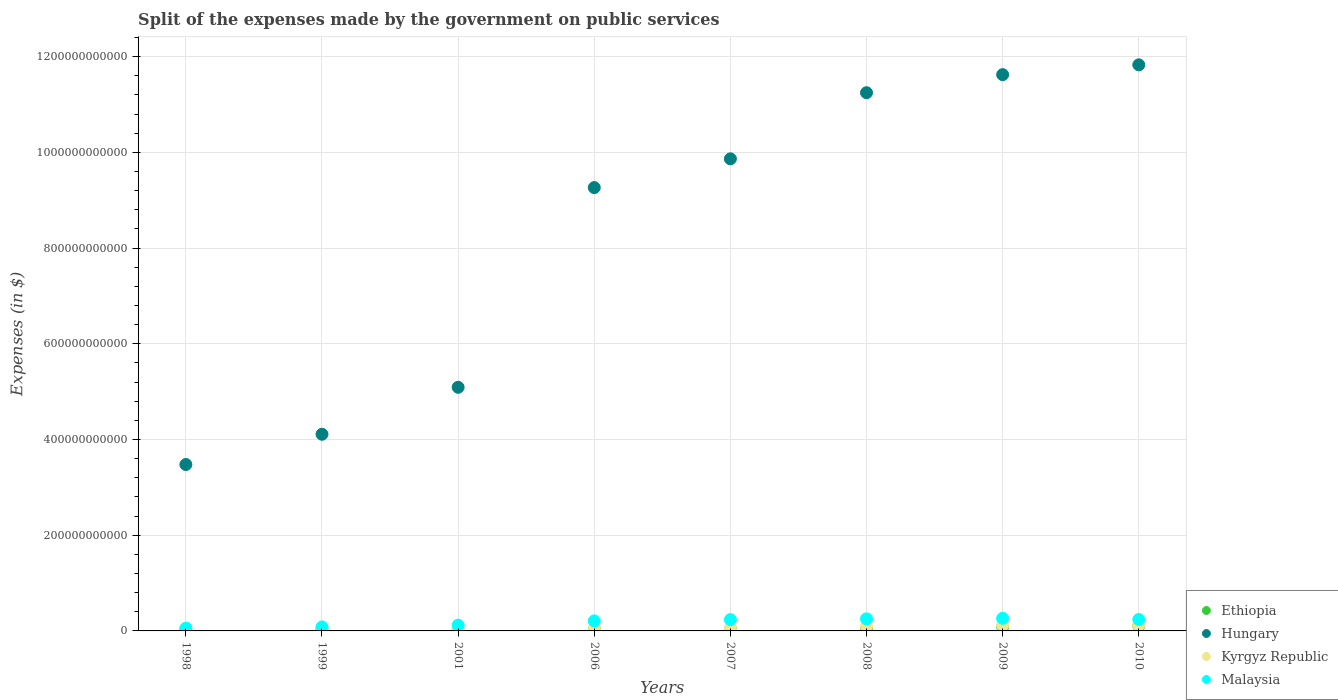Is the number of dotlines equal to the number of legend labels?
Your answer should be compact. Yes. What is the expenses made by the government on public services in Hungary in 2001?
Give a very brief answer. 5.09e+11. Across all years, what is the maximum expenses made by the government on public services in Ethiopia?
Your response must be concise. 1.04e+1. Across all years, what is the minimum expenses made by the government on public services in Ethiopia?
Ensure brevity in your answer.  2.20e+09. In which year was the expenses made by the government on public services in Hungary maximum?
Provide a succinct answer. 2010. What is the total expenses made by the government on public services in Kyrgyz Republic in the graph?
Your answer should be very brief. 5.29e+1. What is the difference between the expenses made by the government on public services in Malaysia in 2007 and that in 2008?
Provide a succinct answer. -1.57e+09. What is the difference between the expenses made by the government on public services in Malaysia in 1998 and the expenses made by the government on public services in Kyrgyz Republic in 1999?
Your response must be concise. 2.43e+09. What is the average expenses made by the government on public services in Hungary per year?
Give a very brief answer. 8.31e+11. In the year 1999, what is the difference between the expenses made by the government on public services in Malaysia and expenses made by the government on public services in Ethiopia?
Make the answer very short. 4.01e+09. In how many years, is the expenses made by the government on public services in Ethiopia greater than 760000000000 $?
Offer a terse response. 0. What is the ratio of the expenses made by the government on public services in Malaysia in 1999 to that in 2009?
Your answer should be very brief. 0.32. Is the difference between the expenses made by the government on public services in Malaysia in 1998 and 1999 greater than the difference between the expenses made by the government on public services in Ethiopia in 1998 and 1999?
Make the answer very short. No. What is the difference between the highest and the second highest expenses made by the government on public services in Malaysia?
Offer a terse response. 1.18e+09. What is the difference between the highest and the lowest expenses made by the government on public services in Hungary?
Make the answer very short. 8.35e+11. In how many years, is the expenses made by the government on public services in Hungary greater than the average expenses made by the government on public services in Hungary taken over all years?
Provide a succinct answer. 5. Is it the case that in every year, the sum of the expenses made by the government on public services in Malaysia and expenses made by the government on public services in Ethiopia  is greater than the sum of expenses made by the government on public services in Hungary and expenses made by the government on public services in Kyrgyz Republic?
Offer a very short reply. Yes. Is it the case that in every year, the sum of the expenses made by the government on public services in Hungary and expenses made by the government on public services in Malaysia  is greater than the expenses made by the government on public services in Ethiopia?
Make the answer very short. Yes. How many years are there in the graph?
Ensure brevity in your answer.  8. What is the difference between two consecutive major ticks on the Y-axis?
Give a very brief answer. 2.00e+11. Does the graph contain grids?
Ensure brevity in your answer.  Yes. How are the legend labels stacked?
Provide a short and direct response. Vertical. What is the title of the graph?
Keep it short and to the point. Split of the expenses made by the government on public services. What is the label or title of the X-axis?
Offer a very short reply. Years. What is the label or title of the Y-axis?
Your response must be concise. Expenses (in $). What is the Expenses (in $) in Ethiopia in 1998?
Provide a short and direct response. 2.27e+09. What is the Expenses (in $) in Hungary in 1998?
Give a very brief answer. 3.48e+11. What is the Expenses (in $) in Kyrgyz Republic in 1998?
Provide a short and direct response. 2.76e+09. What is the Expenses (in $) in Malaysia in 1998?
Give a very brief answer. 5.80e+09. What is the Expenses (in $) in Ethiopia in 1999?
Provide a succinct answer. 4.43e+09. What is the Expenses (in $) of Hungary in 1999?
Your response must be concise. 4.11e+11. What is the Expenses (in $) in Kyrgyz Republic in 1999?
Give a very brief answer. 3.37e+09. What is the Expenses (in $) of Malaysia in 1999?
Give a very brief answer. 8.44e+09. What is the Expenses (in $) in Ethiopia in 2001?
Your response must be concise. 2.20e+09. What is the Expenses (in $) of Hungary in 2001?
Provide a short and direct response. 5.09e+11. What is the Expenses (in $) of Kyrgyz Republic in 2001?
Your answer should be compact. 3.95e+09. What is the Expenses (in $) in Malaysia in 2001?
Your answer should be compact. 1.19e+1. What is the Expenses (in $) in Ethiopia in 2006?
Provide a succinct answer. 4.31e+09. What is the Expenses (in $) in Hungary in 2006?
Offer a terse response. 9.26e+11. What is the Expenses (in $) of Kyrgyz Republic in 2006?
Your answer should be compact. 4.35e+09. What is the Expenses (in $) of Malaysia in 2006?
Make the answer very short. 2.09e+1. What is the Expenses (in $) of Ethiopia in 2007?
Your answer should be very brief. 4.71e+09. What is the Expenses (in $) in Hungary in 2007?
Your answer should be very brief. 9.87e+11. What is the Expenses (in $) of Kyrgyz Republic in 2007?
Your response must be concise. 6.37e+09. What is the Expenses (in $) of Malaysia in 2007?
Your answer should be compact. 2.36e+1. What is the Expenses (in $) of Ethiopia in 2008?
Keep it short and to the point. 5.04e+09. What is the Expenses (in $) of Hungary in 2008?
Provide a short and direct response. 1.12e+12. What is the Expenses (in $) in Kyrgyz Republic in 2008?
Offer a terse response. 9.08e+09. What is the Expenses (in $) in Malaysia in 2008?
Provide a short and direct response. 2.52e+1. What is the Expenses (in $) of Ethiopia in 2009?
Offer a very short reply. 8.59e+09. What is the Expenses (in $) in Hungary in 2009?
Your answer should be compact. 1.16e+12. What is the Expenses (in $) of Kyrgyz Republic in 2009?
Offer a terse response. 1.13e+1. What is the Expenses (in $) in Malaysia in 2009?
Offer a terse response. 2.64e+1. What is the Expenses (in $) of Ethiopia in 2010?
Provide a succinct answer. 1.04e+1. What is the Expenses (in $) of Hungary in 2010?
Provide a short and direct response. 1.18e+12. What is the Expenses (in $) of Kyrgyz Republic in 2010?
Make the answer very short. 1.17e+1. What is the Expenses (in $) of Malaysia in 2010?
Provide a succinct answer. 2.38e+1. Across all years, what is the maximum Expenses (in $) of Ethiopia?
Your response must be concise. 1.04e+1. Across all years, what is the maximum Expenses (in $) in Hungary?
Make the answer very short. 1.18e+12. Across all years, what is the maximum Expenses (in $) of Kyrgyz Republic?
Provide a short and direct response. 1.17e+1. Across all years, what is the maximum Expenses (in $) of Malaysia?
Offer a terse response. 2.64e+1. Across all years, what is the minimum Expenses (in $) of Ethiopia?
Offer a terse response. 2.20e+09. Across all years, what is the minimum Expenses (in $) in Hungary?
Give a very brief answer. 3.48e+11. Across all years, what is the minimum Expenses (in $) in Kyrgyz Republic?
Your answer should be compact. 2.76e+09. Across all years, what is the minimum Expenses (in $) of Malaysia?
Provide a succinct answer. 5.80e+09. What is the total Expenses (in $) of Ethiopia in the graph?
Give a very brief answer. 4.19e+1. What is the total Expenses (in $) in Hungary in the graph?
Offer a terse response. 6.65e+12. What is the total Expenses (in $) of Kyrgyz Republic in the graph?
Provide a short and direct response. 5.29e+1. What is the total Expenses (in $) in Malaysia in the graph?
Make the answer very short. 1.46e+11. What is the difference between the Expenses (in $) of Ethiopia in 1998 and that in 1999?
Offer a terse response. -2.16e+09. What is the difference between the Expenses (in $) of Hungary in 1998 and that in 1999?
Your answer should be very brief. -6.32e+1. What is the difference between the Expenses (in $) in Kyrgyz Republic in 1998 and that in 1999?
Ensure brevity in your answer.  -6.06e+08. What is the difference between the Expenses (in $) of Malaysia in 1998 and that in 1999?
Offer a very short reply. -2.65e+09. What is the difference between the Expenses (in $) of Ethiopia in 1998 and that in 2001?
Offer a very short reply. 7.11e+07. What is the difference between the Expenses (in $) of Hungary in 1998 and that in 2001?
Keep it short and to the point. -1.61e+11. What is the difference between the Expenses (in $) of Kyrgyz Republic in 1998 and that in 2001?
Ensure brevity in your answer.  -1.18e+09. What is the difference between the Expenses (in $) of Malaysia in 1998 and that in 2001?
Ensure brevity in your answer.  -6.14e+09. What is the difference between the Expenses (in $) of Ethiopia in 1998 and that in 2006?
Your response must be concise. -2.05e+09. What is the difference between the Expenses (in $) in Hungary in 1998 and that in 2006?
Make the answer very short. -5.79e+11. What is the difference between the Expenses (in $) of Kyrgyz Republic in 1998 and that in 2006?
Your answer should be compact. -1.58e+09. What is the difference between the Expenses (in $) of Malaysia in 1998 and that in 2006?
Provide a succinct answer. -1.51e+1. What is the difference between the Expenses (in $) of Ethiopia in 1998 and that in 2007?
Provide a short and direct response. -2.44e+09. What is the difference between the Expenses (in $) of Hungary in 1998 and that in 2007?
Provide a short and direct response. -6.39e+11. What is the difference between the Expenses (in $) of Kyrgyz Republic in 1998 and that in 2007?
Your answer should be very brief. -3.61e+09. What is the difference between the Expenses (in $) of Malaysia in 1998 and that in 2007?
Your response must be concise. -1.78e+1. What is the difference between the Expenses (in $) of Ethiopia in 1998 and that in 2008?
Make the answer very short. -2.77e+09. What is the difference between the Expenses (in $) in Hungary in 1998 and that in 2008?
Offer a very short reply. -7.77e+11. What is the difference between the Expenses (in $) of Kyrgyz Republic in 1998 and that in 2008?
Your answer should be compact. -6.32e+09. What is the difference between the Expenses (in $) in Malaysia in 1998 and that in 2008?
Give a very brief answer. -1.94e+1. What is the difference between the Expenses (in $) of Ethiopia in 1998 and that in 2009?
Provide a succinct answer. -6.32e+09. What is the difference between the Expenses (in $) of Hungary in 1998 and that in 2009?
Your answer should be compact. -8.15e+11. What is the difference between the Expenses (in $) in Kyrgyz Republic in 1998 and that in 2009?
Keep it short and to the point. -8.59e+09. What is the difference between the Expenses (in $) in Malaysia in 1998 and that in 2009?
Your answer should be compact. -2.06e+1. What is the difference between the Expenses (in $) of Ethiopia in 1998 and that in 2010?
Ensure brevity in your answer.  -8.10e+09. What is the difference between the Expenses (in $) in Hungary in 1998 and that in 2010?
Your answer should be compact. -8.35e+11. What is the difference between the Expenses (in $) of Kyrgyz Republic in 1998 and that in 2010?
Provide a succinct answer. -8.95e+09. What is the difference between the Expenses (in $) of Malaysia in 1998 and that in 2010?
Offer a very short reply. -1.80e+1. What is the difference between the Expenses (in $) in Ethiopia in 1999 and that in 2001?
Provide a succinct answer. 2.23e+09. What is the difference between the Expenses (in $) in Hungary in 1999 and that in 2001?
Offer a terse response. -9.81e+1. What is the difference between the Expenses (in $) in Kyrgyz Republic in 1999 and that in 2001?
Your answer should be compact. -5.77e+08. What is the difference between the Expenses (in $) of Malaysia in 1999 and that in 2001?
Make the answer very short. -3.49e+09. What is the difference between the Expenses (in $) of Ethiopia in 1999 and that in 2006?
Your response must be concise. 1.16e+08. What is the difference between the Expenses (in $) in Hungary in 1999 and that in 2006?
Keep it short and to the point. -5.15e+11. What is the difference between the Expenses (in $) in Kyrgyz Republic in 1999 and that in 2006?
Ensure brevity in your answer.  -9.79e+08. What is the difference between the Expenses (in $) in Malaysia in 1999 and that in 2006?
Make the answer very short. -1.25e+1. What is the difference between the Expenses (in $) of Ethiopia in 1999 and that in 2007?
Ensure brevity in your answer.  -2.76e+08. What is the difference between the Expenses (in $) in Hungary in 1999 and that in 2007?
Give a very brief answer. -5.76e+11. What is the difference between the Expenses (in $) in Kyrgyz Republic in 1999 and that in 2007?
Offer a very short reply. -3.00e+09. What is the difference between the Expenses (in $) in Malaysia in 1999 and that in 2007?
Provide a short and direct response. -1.52e+1. What is the difference between the Expenses (in $) in Ethiopia in 1999 and that in 2008?
Offer a very short reply. -6.10e+08. What is the difference between the Expenses (in $) in Hungary in 1999 and that in 2008?
Provide a succinct answer. -7.14e+11. What is the difference between the Expenses (in $) in Kyrgyz Republic in 1999 and that in 2008?
Ensure brevity in your answer.  -5.71e+09. What is the difference between the Expenses (in $) in Malaysia in 1999 and that in 2008?
Give a very brief answer. -1.68e+1. What is the difference between the Expenses (in $) in Ethiopia in 1999 and that in 2009?
Give a very brief answer. -4.16e+09. What is the difference between the Expenses (in $) in Hungary in 1999 and that in 2009?
Your response must be concise. -7.52e+11. What is the difference between the Expenses (in $) in Kyrgyz Republic in 1999 and that in 2009?
Your response must be concise. -7.98e+09. What is the difference between the Expenses (in $) in Malaysia in 1999 and that in 2009?
Ensure brevity in your answer.  -1.79e+1. What is the difference between the Expenses (in $) of Ethiopia in 1999 and that in 2010?
Offer a very short reply. -5.93e+09. What is the difference between the Expenses (in $) of Hungary in 1999 and that in 2010?
Provide a succinct answer. -7.72e+11. What is the difference between the Expenses (in $) of Kyrgyz Republic in 1999 and that in 2010?
Your answer should be very brief. -8.34e+09. What is the difference between the Expenses (in $) in Malaysia in 1999 and that in 2010?
Ensure brevity in your answer.  -1.54e+1. What is the difference between the Expenses (in $) of Ethiopia in 2001 and that in 2006?
Your answer should be compact. -2.12e+09. What is the difference between the Expenses (in $) of Hungary in 2001 and that in 2006?
Your answer should be very brief. -4.17e+11. What is the difference between the Expenses (in $) in Kyrgyz Republic in 2001 and that in 2006?
Provide a short and direct response. -4.01e+08. What is the difference between the Expenses (in $) of Malaysia in 2001 and that in 2006?
Offer a very short reply. -8.99e+09. What is the difference between the Expenses (in $) in Ethiopia in 2001 and that in 2007?
Make the answer very short. -2.51e+09. What is the difference between the Expenses (in $) in Hungary in 2001 and that in 2007?
Provide a succinct answer. -4.77e+11. What is the difference between the Expenses (in $) of Kyrgyz Republic in 2001 and that in 2007?
Your response must be concise. -2.42e+09. What is the difference between the Expenses (in $) in Malaysia in 2001 and that in 2007?
Offer a terse response. -1.17e+1. What is the difference between the Expenses (in $) of Ethiopia in 2001 and that in 2008?
Provide a short and direct response. -2.84e+09. What is the difference between the Expenses (in $) in Hungary in 2001 and that in 2008?
Your answer should be very brief. -6.16e+11. What is the difference between the Expenses (in $) of Kyrgyz Republic in 2001 and that in 2008?
Make the answer very short. -5.13e+09. What is the difference between the Expenses (in $) in Malaysia in 2001 and that in 2008?
Provide a succinct answer. -1.33e+1. What is the difference between the Expenses (in $) of Ethiopia in 2001 and that in 2009?
Your answer should be compact. -6.39e+09. What is the difference between the Expenses (in $) of Hungary in 2001 and that in 2009?
Offer a terse response. -6.53e+11. What is the difference between the Expenses (in $) of Kyrgyz Republic in 2001 and that in 2009?
Ensure brevity in your answer.  -7.40e+09. What is the difference between the Expenses (in $) in Malaysia in 2001 and that in 2009?
Keep it short and to the point. -1.44e+1. What is the difference between the Expenses (in $) in Ethiopia in 2001 and that in 2010?
Provide a short and direct response. -8.17e+09. What is the difference between the Expenses (in $) in Hungary in 2001 and that in 2010?
Your answer should be very brief. -6.74e+11. What is the difference between the Expenses (in $) of Kyrgyz Republic in 2001 and that in 2010?
Offer a very short reply. -7.76e+09. What is the difference between the Expenses (in $) of Malaysia in 2001 and that in 2010?
Your response must be concise. -1.19e+1. What is the difference between the Expenses (in $) of Ethiopia in 2006 and that in 2007?
Keep it short and to the point. -3.93e+08. What is the difference between the Expenses (in $) of Hungary in 2006 and that in 2007?
Make the answer very short. -6.01e+1. What is the difference between the Expenses (in $) in Kyrgyz Republic in 2006 and that in 2007?
Offer a very short reply. -2.02e+09. What is the difference between the Expenses (in $) of Malaysia in 2006 and that in 2007?
Your response must be concise. -2.70e+09. What is the difference between the Expenses (in $) in Ethiopia in 2006 and that in 2008?
Offer a very short reply. -7.27e+08. What is the difference between the Expenses (in $) in Hungary in 2006 and that in 2008?
Ensure brevity in your answer.  -1.98e+11. What is the difference between the Expenses (in $) in Kyrgyz Republic in 2006 and that in 2008?
Ensure brevity in your answer.  -4.73e+09. What is the difference between the Expenses (in $) in Malaysia in 2006 and that in 2008?
Ensure brevity in your answer.  -4.27e+09. What is the difference between the Expenses (in $) of Ethiopia in 2006 and that in 2009?
Provide a succinct answer. -4.27e+09. What is the difference between the Expenses (in $) in Hungary in 2006 and that in 2009?
Keep it short and to the point. -2.36e+11. What is the difference between the Expenses (in $) of Kyrgyz Republic in 2006 and that in 2009?
Offer a terse response. -7.00e+09. What is the difference between the Expenses (in $) of Malaysia in 2006 and that in 2009?
Your answer should be compact. -5.45e+09. What is the difference between the Expenses (in $) of Ethiopia in 2006 and that in 2010?
Offer a terse response. -6.05e+09. What is the difference between the Expenses (in $) of Hungary in 2006 and that in 2010?
Keep it short and to the point. -2.57e+11. What is the difference between the Expenses (in $) in Kyrgyz Republic in 2006 and that in 2010?
Ensure brevity in your answer.  -7.36e+09. What is the difference between the Expenses (in $) in Malaysia in 2006 and that in 2010?
Offer a terse response. -2.92e+09. What is the difference between the Expenses (in $) of Ethiopia in 2007 and that in 2008?
Offer a very short reply. -3.34e+08. What is the difference between the Expenses (in $) of Hungary in 2007 and that in 2008?
Keep it short and to the point. -1.38e+11. What is the difference between the Expenses (in $) in Kyrgyz Republic in 2007 and that in 2008?
Give a very brief answer. -2.71e+09. What is the difference between the Expenses (in $) of Malaysia in 2007 and that in 2008?
Provide a succinct answer. -1.57e+09. What is the difference between the Expenses (in $) of Ethiopia in 2007 and that in 2009?
Provide a short and direct response. -3.88e+09. What is the difference between the Expenses (in $) of Hungary in 2007 and that in 2009?
Make the answer very short. -1.76e+11. What is the difference between the Expenses (in $) in Kyrgyz Republic in 2007 and that in 2009?
Give a very brief answer. -4.98e+09. What is the difference between the Expenses (in $) of Malaysia in 2007 and that in 2009?
Your response must be concise. -2.75e+09. What is the difference between the Expenses (in $) of Ethiopia in 2007 and that in 2010?
Your answer should be very brief. -5.66e+09. What is the difference between the Expenses (in $) in Hungary in 2007 and that in 2010?
Your answer should be very brief. -1.96e+11. What is the difference between the Expenses (in $) in Kyrgyz Republic in 2007 and that in 2010?
Ensure brevity in your answer.  -5.34e+09. What is the difference between the Expenses (in $) of Malaysia in 2007 and that in 2010?
Your answer should be very brief. -2.18e+08. What is the difference between the Expenses (in $) of Ethiopia in 2008 and that in 2009?
Keep it short and to the point. -3.55e+09. What is the difference between the Expenses (in $) in Hungary in 2008 and that in 2009?
Your answer should be very brief. -3.77e+1. What is the difference between the Expenses (in $) of Kyrgyz Republic in 2008 and that in 2009?
Ensure brevity in your answer.  -2.27e+09. What is the difference between the Expenses (in $) of Malaysia in 2008 and that in 2009?
Your answer should be compact. -1.18e+09. What is the difference between the Expenses (in $) of Ethiopia in 2008 and that in 2010?
Keep it short and to the point. -5.32e+09. What is the difference between the Expenses (in $) in Hungary in 2008 and that in 2010?
Ensure brevity in your answer.  -5.83e+1. What is the difference between the Expenses (in $) in Kyrgyz Republic in 2008 and that in 2010?
Give a very brief answer. -2.63e+09. What is the difference between the Expenses (in $) of Malaysia in 2008 and that in 2010?
Your answer should be very brief. 1.36e+09. What is the difference between the Expenses (in $) in Ethiopia in 2009 and that in 2010?
Offer a very short reply. -1.78e+09. What is the difference between the Expenses (in $) in Hungary in 2009 and that in 2010?
Your answer should be very brief. -2.05e+1. What is the difference between the Expenses (in $) of Kyrgyz Republic in 2009 and that in 2010?
Provide a succinct answer. -3.61e+08. What is the difference between the Expenses (in $) of Malaysia in 2009 and that in 2010?
Your response must be concise. 2.53e+09. What is the difference between the Expenses (in $) in Ethiopia in 1998 and the Expenses (in $) in Hungary in 1999?
Offer a terse response. -4.09e+11. What is the difference between the Expenses (in $) in Ethiopia in 1998 and the Expenses (in $) in Kyrgyz Republic in 1999?
Keep it short and to the point. -1.10e+09. What is the difference between the Expenses (in $) in Ethiopia in 1998 and the Expenses (in $) in Malaysia in 1999?
Ensure brevity in your answer.  -6.18e+09. What is the difference between the Expenses (in $) of Hungary in 1998 and the Expenses (in $) of Kyrgyz Republic in 1999?
Keep it short and to the point. 3.44e+11. What is the difference between the Expenses (in $) of Hungary in 1998 and the Expenses (in $) of Malaysia in 1999?
Your response must be concise. 3.39e+11. What is the difference between the Expenses (in $) of Kyrgyz Republic in 1998 and the Expenses (in $) of Malaysia in 1999?
Your response must be concise. -5.68e+09. What is the difference between the Expenses (in $) of Ethiopia in 1998 and the Expenses (in $) of Hungary in 2001?
Your answer should be compact. -5.07e+11. What is the difference between the Expenses (in $) in Ethiopia in 1998 and the Expenses (in $) in Kyrgyz Republic in 2001?
Your answer should be compact. -1.68e+09. What is the difference between the Expenses (in $) in Ethiopia in 1998 and the Expenses (in $) in Malaysia in 2001?
Provide a succinct answer. -9.67e+09. What is the difference between the Expenses (in $) of Hungary in 1998 and the Expenses (in $) of Kyrgyz Republic in 2001?
Offer a terse response. 3.44e+11. What is the difference between the Expenses (in $) in Hungary in 1998 and the Expenses (in $) in Malaysia in 2001?
Keep it short and to the point. 3.36e+11. What is the difference between the Expenses (in $) in Kyrgyz Republic in 1998 and the Expenses (in $) in Malaysia in 2001?
Provide a succinct answer. -9.17e+09. What is the difference between the Expenses (in $) of Ethiopia in 1998 and the Expenses (in $) of Hungary in 2006?
Your response must be concise. -9.24e+11. What is the difference between the Expenses (in $) of Ethiopia in 1998 and the Expenses (in $) of Kyrgyz Republic in 2006?
Offer a very short reply. -2.08e+09. What is the difference between the Expenses (in $) of Ethiopia in 1998 and the Expenses (in $) of Malaysia in 2006?
Your answer should be compact. -1.87e+1. What is the difference between the Expenses (in $) in Hungary in 1998 and the Expenses (in $) in Kyrgyz Republic in 2006?
Give a very brief answer. 3.43e+11. What is the difference between the Expenses (in $) in Hungary in 1998 and the Expenses (in $) in Malaysia in 2006?
Make the answer very short. 3.27e+11. What is the difference between the Expenses (in $) in Kyrgyz Republic in 1998 and the Expenses (in $) in Malaysia in 2006?
Ensure brevity in your answer.  -1.82e+1. What is the difference between the Expenses (in $) of Ethiopia in 1998 and the Expenses (in $) of Hungary in 2007?
Provide a short and direct response. -9.84e+11. What is the difference between the Expenses (in $) of Ethiopia in 1998 and the Expenses (in $) of Kyrgyz Republic in 2007?
Keep it short and to the point. -4.10e+09. What is the difference between the Expenses (in $) of Ethiopia in 1998 and the Expenses (in $) of Malaysia in 2007?
Offer a very short reply. -2.14e+1. What is the difference between the Expenses (in $) of Hungary in 1998 and the Expenses (in $) of Kyrgyz Republic in 2007?
Give a very brief answer. 3.41e+11. What is the difference between the Expenses (in $) in Hungary in 1998 and the Expenses (in $) in Malaysia in 2007?
Offer a very short reply. 3.24e+11. What is the difference between the Expenses (in $) of Kyrgyz Republic in 1998 and the Expenses (in $) of Malaysia in 2007?
Keep it short and to the point. -2.09e+1. What is the difference between the Expenses (in $) in Ethiopia in 1998 and the Expenses (in $) in Hungary in 2008?
Ensure brevity in your answer.  -1.12e+12. What is the difference between the Expenses (in $) in Ethiopia in 1998 and the Expenses (in $) in Kyrgyz Republic in 2008?
Your answer should be compact. -6.81e+09. What is the difference between the Expenses (in $) of Ethiopia in 1998 and the Expenses (in $) of Malaysia in 2008?
Ensure brevity in your answer.  -2.29e+1. What is the difference between the Expenses (in $) in Hungary in 1998 and the Expenses (in $) in Kyrgyz Republic in 2008?
Provide a succinct answer. 3.39e+11. What is the difference between the Expenses (in $) in Hungary in 1998 and the Expenses (in $) in Malaysia in 2008?
Provide a succinct answer. 3.23e+11. What is the difference between the Expenses (in $) in Kyrgyz Republic in 1998 and the Expenses (in $) in Malaysia in 2008?
Your response must be concise. -2.24e+1. What is the difference between the Expenses (in $) in Ethiopia in 1998 and the Expenses (in $) in Hungary in 2009?
Your answer should be very brief. -1.16e+12. What is the difference between the Expenses (in $) in Ethiopia in 1998 and the Expenses (in $) in Kyrgyz Republic in 2009?
Offer a very short reply. -9.08e+09. What is the difference between the Expenses (in $) of Ethiopia in 1998 and the Expenses (in $) of Malaysia in 2009?
Your answer should be compact. -2.41e+1. What is the difference between the Expenses (in $) in Hungary in 1998 and the Expenses (in $) in Kyrgyz Republic in 2009?
Provide a short and direct response. 3.36e+11. What is the difference between the Expenses (in $) in Hungary in 1998 and the Expenses (in $) in Malaysia in 2009?
Your answer should be compact. 3.21e+11. What is the difference between the Expenses (in $) in Kyrgyz Republic in 1998 and the Expenses (in $) in Malaysia in 2009?
Provide a succinct answer. -2.36e+1. What is the difference between the Expenses (in $) in Ethiopia in 1998 and the Expenses (in $) in Hungary in 2010?
Give a very brief answer. -1.18e+12. What is the difference between the Expenses (in $) of Ethiopia in 1998 and the Expenses (in $) of Kyrgyz Republic in 2010?
Provide a succinct answer. -9.44e+09. What is the difference between the Expenses (in $) of Ethiopia in 1998 and the Expenses (in $) of Malaysia in 2010?
Your answer should be very brief. -2.16e+1. What is the difference between the Expenses (in $) in Hungary in 1998 and the Expenses (in $) in Kyrgyz Republic in 2010?
Ensure brevity in your answer.  3.36e+11. What is the difference between the Expenses (in $) in Hungary in 1998 and the Expenses (in $) in Malaysia in 2010?
Your response must be concise. 3.24e+11. What is the difference between the Expenses (in $) of Kyrgyz Republic in 1998 and the Expenses (in $) of Malaysia in 2010?
Make the answer very short. -2.11e+1. What is the difference between the Expenses (in $) of Ethiopia in 1999 and the Expenses (in $) of Hungary in 2001?
Your response must be concise. -5.05e+11. What is the difference between the Expenses (in $) in Ethiopia in 1999 and the Expenses (in $) in Kyrgyz Republic in 2001?
Offer a very short reply. 4.84e+08. What is the difference between the Expenses (in $) in Ethiopia in 1999 and the Expenses (in $) in Malaysia in 2001?
Provide a succinct answer. -7.51e+09. What is the difference between the Expenses (in $) of Hungary in 1999 and the Expenses (in $) of Kyrgyz Republic in 2001?
Your answer should be very brief. 4.07e+11. What is the difference between the Expenses (in $) of Hungary in 1999 and the Expenses (in $) of Malaysia in 2001?
Keep it short and to the point. 3.99e+11. What is the difference between the Expenses (in $) of Kyrgyz Republic in 1999 and the Expenses (in $) of Malaysia in 2001?
Provide a succinct answer. -8.57e+09. What is the difference between the Expenses (in $) in Ethiopia in 1999 and the Expenses (in $) in Hungary in 2006?
Provide a succinct answer. -9.22e+11. What is the difference between the Expenses (in $) of Ethiopia in 1999 and the Expenses (in $) of Kyrgyz Republic in 2006?
Provide a succinct answer. 8.22e+07. What is the difference between the Expenses (in $) in Ethiopia in 1999 and the Expenses (in $) in Malaysia in 2006?
Provide a succinct answer. -1.65e+1. What is the difference between the Expenses (in $) in Hungary in 1999 and the Expenses (in $) in Kyrgyz Republic in 2006?
Your response must be concise. 4.07e+11. What is the difference between the Expenses (in $) of Hungary in 1999 and the Expenses (in $) of Malaysia in 2006?
Offer a very short reply. 3.90e+11. What is the difference between the Expenses (in $) of Kyrgyz Republic in 1999 and the Expenses (in $) of Malaysia in 2006?
Give a very brief answer. -1.76e+1. What is the difference between the Expenses (in $) in Ethiopia in 1999 and the Expenses (in $) in Hungary in 2007?
Provide a succinct answer. -9.82e+11. What is the difference between the Expenses (in $) of Ethiopia in 1999 and the Expenses (in $) of Kyrgyz Republic in 2007?
Your answer should be compact. -1.94e+09. What is the difference between the Expenses (in $) in Ethiopia in 1999 and the Expenses (in $) in Malaysia in 2007?
Provide a short and direct response. -1.92e+1. What is the difference between the Expenses (in $) of Hungary in 1999 and the Expenses (in $) of Kyrgyz Republic in 2007?
Your answer should be very brief. 4.05e+11. What is the difference between the Expenses (in $) in Hungary in 1999 and the Expenses (in $) in Malaysia in 2007?
Offer a terse response. 3.87e+11. What is the difference between the Expenses (in $) in Kyrgyz Republic in 1999 and the Expenses (in $) in Malaysia in 2007?
Offer a very short reply. -2.03e+1. What is the difference between the Expenses (in $) of Ethiopia in 1999 and the Expenses (in $) of Hungary in 2008?
Your answer should be very brief. -1.12e+12. What is the difference between the Expenses (in $) of Ethiopia in 1999 and the Expenses (in $) of Kyrgyz Republic in 2008?
Offer a terse response. -4.65e+09. What is the difference between the Expenses (in $) of Ethiopia in 1999 and the Expenses (in $) of Malaysia in 2008?
Make the answer very short. -2.08e+1. What is the difference between the Expenses (in $) in Hungary in 1999 and the Expenses (in $) in Kyrgyz Republic in 2008?
Make the answer very short. 4.02e+11. What is the difference between the Expenses (in $) of Hungary in 1999 and the Expenses (in $) of Malaysia in 2008?
Your response must be concise. 3.86e+11. What is the difference between the Expenses (in $) of Kyrgyz Republic in 1999 and the Expenses (in $) of Malaysia in 2008?
Provide a short and direct response. -2.18e+1. What is the difference between the Expenses (in $) in Ethiopia in 1999 and the Expenses (in $) in Hungary in 2009?
Keep it short and to the point. -1.16e+12. What is the difference between the Expenses (in $) of Ethiopia in 1999 and the Expenses (in $) of Kyrgyz Republic in 2009?
Provide a succinct answer. -6.92e+09. What is the difference between the Expenses (in $) of Ethiopia in 1999 and the Expenses (in $) of Malaysia in 2009?
Offer a very short reply. -2.19e+1. What is the difference between the Expenses (in $) of Hungary in 1999 and the Expenses (in $) of Kyrgyz Republic in 2009?
Offer a terse response. 4.00e+11. What is the difference between the Expenses (in $) of Hungary in 1999 and the Expenses (in $) of Malaysia in 2009?
Ensure brevity in your answer.  3.85e+11. What is the difference between the Expenses (in $) in Kyrgyz Republic in 1999 and the Expenses (in $) in Malaysia in 2009?
Your response must be concise. -2.30e+1. What is the difference between the Expenses (in $) of Ethiopia in 1999 and the Expenses (in $) of Hungary in 2010?
Your response must be concise. -1.18e+12. What is the difference between the Expenses (in $) of Ethiopia in 1999 and the Expenses (in $) of Kyrgyz Republic in 2010?
Your answer should be compact. -7.28e+09. What is the difference between the Expenses (in $) in Ethiopia in 1999 and the Expenses (in $) in Malaysia in 2010?
Ensure brevity in your answer.  -1.94e+1. What is the difference between the Expenses (in $) in Hungary in 1999 and the Expenses (in $) in Kyrgyz Republic in 2010?
Your answer should be compact. 3.99e+11. What is the difference between the Expenses (in $) of Hungary in 1999 and the Expenses (in $) of Malaysia in 2010?
Your answer should be very brief. 3.87e+11. What is the difference between the Expenses (in $) in Kyrgyz Republic in 1999 and the Expenses (in $) in Malaysia in 2010?
Make the answer very short. -2.05e+1. What is the difference between the Expenses (in $) in Ethiopia in 2001 and the Expenses (in $) in Hungary in 2006?
Provide a succinct answer. -9.24e+11. What is the difference between the Expenses (in $) in Ethiopia in 2001 and the Expenses (in $) in Kyrgyz Republic in 2006?
Make the answer very short. -2.15e+09. What is the difference between the Expenses (in $) in Ethiopia in 2001 and the Expenses (in $) in Malaysia in 2006?
Keep it short and to the point. -1.87e+1. What is the difference between the Expenses (in $) of Hungary in 2001 and the Expenses (in $) of Kyrgyz Republic in 2006?
Keep it short and to the point. 5.05e+11. What is the difference between the Expenses (in $) in Hungary in 2001 and the Expenses (in $) in Malaysia in 2006?
Make the answer very short. 4.88e+11. What is the difference between the Expenses (in $) in Kyrgyz Republic in 2001 and the Expenses (in $) in Malaysia in 2006?
Offer a very short reply. -1.70e+1. What is the difference between the Expenses (in $) in Ethiopia in 2001 and the Expenses (in $) in Hungary in 2007?
Ensure brevity in your answer.  -9.84e+11. What is the difference between the Expenses (in $) of Ethiopia in 2001 and the Expenses (in $) of Kyrgyz Republic in 2007?
Keep it short and to the point. -4.17e+09. What is the difference between the Expenses (in $) of Ethiopia in 2001 and the Expenses (in $) of Malaysia in 2007?
Offer a very short reply. -2.14e+1. What is the difference between the Expenses (in $) in Hungary in 2001 and the Expenses (in $) in Kyrgyz Republic in 2007?
Offer a terse response. 5.03e+11. What is the difference between the Expenses (in $) in Hungary in 2001 and the Expenses (in $) in Malaysia in 2007?
Give a very brief answer. 4.85e+11. What is the difference between the Expenses (in $) of Kyrgyz Republic in 2001 and the Expenses (in $) of Malaysia in 2007?
Make the answer very short. -1.97e+1. What is the difference between the Expenses (in $) in Ethiopia in 2001 and the Expenses (in $) in Hungary in 2008?
Provide a succinct answer. -1.12e+12. What is the difference between the Expenses (in $) in Ethiopia in 2001 and the Expenses (in $) in Kyrgyz Republic in 2008?
Your response must be concise. -6.88e+09. What is the difference between the Expenses (in $) of Ethiopia in 2001 and the Expenses (in $) of Malaysia in 2008?
Ensure brevity in your answer.  -2.30e+1. What is the difference between the Expenses (in $) in Hungary in 2001 and the Expenses (in $) in Kyrgyz Republic in 2008?
Provide a short and direct response. 5.00e+11. What is the difference between the Expenses (in $) in Hungary in 2001 and the Expenses (in $) in Malaysia in 2008?
Make the answer very short. 4.84e+11. What is the difference between the Expenses (in $) of Kyrgyz Republic in 2001 and the Expenses (in $) of Malaysia in 2008?
Your answer should be very brief. -2.13e+1. What is the difference between the Expenses (in $) of Ethiopia in 2001 and the Expenses (in $) of Hungary in 2009?
Offer a very short reply. -1.16e+12. What is the difference between the Expenses (in $) in Ethiopia in 2001 and the Expenses (in $) in Kyrgyz Republic in 2009?
Your answer should be very brief. -9.15e+09. What is the difference between the Expenses (in $) in Ethiopia in 2001 and the Expenses (in $) in Malaysia in 2009?
Provide a succinct answer. -2.42e+1. What is the difference between the Expenses (in $) in Hungary in 2001 and the Expenses (in $) in Kyrgyz Republic in 2009?
Give a very brief answer. 4.98e+11. What is the difference between the Expenses (in $) in Hungary in 2001 and the Expenses (in $) in Malaysia in 2009?
Provide a short and direct response. 4.83e+11. What is the difference between the Expenses (in $) of Kyrgyz Republic in 2001 and the Expenses (in $) of Malaysia in 2009?
Give a very brief answer. -2.24e+1. What is the difference between the Expenses (in $) in Ethiopia in 2001 and the Expenses (in $) in Hungary in 2010?
Provide a succinct answer. -1.18e+12. What is the difference between the Expenses (in $) of Ethiopia in 2001 and the Expenses (in $) of Kyrgyz Republic in 2010?
Give a very brief answer. -9.51e+09. What is the difference between the Expenses (in $) in Ethiopia in 2001 and the Expenses (in $) in Malaysia in 2010?
Provide a succinct answer. -2.16e+1. What is the difference between the Expenses (in $) of Hungary in 2001 and the Expenses (in $) of Kyrgyz Republic in 2010?
Your answer should be compact. 4.97e+11. What is the difference between the Expenses (in $) in Hungary in 2001 and the Expenses (in $) in Malaysia in 2010?
Your answer should be very brief. 4.85e+11. What is the difference between the Expenses (in $) in Kyrgyz Republic in 2001 and the Expenses (in $) in Malaysia in 2010?
Keep it short and to the point. -1.99e+1. What is the difference between the Expenses (in $) in Ethiopia in 2006 and the Expenses (in $) in Hungary in 2007?
Your answer should be very brief. -9.82e+11. What is the difference between the Expenses (in $) of Ethiopia in 2006 and the Expenses (in $) of Kyrgyz Republic in 2007?
Make the answer very short. -2.06e+09. What is the difference between the Expenses (in $) in Ethiopia in 2006 and the Expenses (in $) in Malaysia in 2007?
Keep it short and to the point. -1.93e+1. What is the difference between the Expenses (in $) of Hungary in 2006 and the Expenses (in $) of Kyrgyz Republic in 2007?
Give a very brief answer. 9.20e+11. What is the difference between the Expenses (in $) in Hungary in 2006 and the Expenses (in $) in Malaysia in 2007?
Make the answer very short. 9.03e+11. What is the difference between the Expenses (in $) in Kyrgyz Republic in 2006 and the Expenses (in $) in Malaysia in 2007?
Make the answer very short. -1.93e+1. What is the difference between the Expenses (in $) of Ethiopia in 2006 and the Expenses (in $) of Hungary in 2008?
Give a very brief answer. -1.12e+12. What is the difference between the Expenses (in $) of Ethiopia in 2006 and the Expenses (in $) of Kyrgyz Republic in 2008?
Keep it short and to the point. -4.77e+09. What is the difference between the Expenses (in $) in Ethiopia in 2006 and the Expenses (in $) in Malaysia in 2008?
Your response must be concise. -2.09e+1. What is the difference between the Expenses (in $) in Hungary in 2006 and the Expenses (in $) in Kyrgyz Republic in 2008?
Your response must be concise. 9.17e+11. What is the difference between the Expenses (in $) in Hungary in 2006 and the Expenses (in $) in Malaysia in 2008?
Give a very brief answer. 9.01e+11. What is the difference between the Expenses (in $) of Kyrgyz Republic in 2006 and the Expenses (in $) of Malaysia in 2008?
Your response must be concise. -2.08e+1. What is the difference between the Expenses (in $) in Ethiopia in 2006 and the Expenses (in $) in Hungary in 2009?
Keep it short and to the point. -1.16e+12. What is the difference between the Expenses (in $) of Ethiopia in 2006 and the Expenses (in $) of Kyrgyz Republic in 2009?
Give a very brief answer. -7.04e+09. What is the difference between the Expenses (in $) in Ethiopia in 2006 and the Expenses (in $) in Malaysia in 2009?
Your answer should be compact. -2.21e+1. What is the difference between the Expenses (in $) of Hungary in 2006 and the Expenses (in $) of Kyrgyz Republic in 2009?
Offer a terse response. 9.15e+11. What is the difference between the Expenses (in $) of Hungary in 2006 and the Expenses (in $) of Malaysia in 2009?
Offer a very short reply. 9.00e+11. What is the difference between the Expenses (in $) in Kyrgyz Republic in 2006 and the Expenses (in $) in Malaysia in 2009?
Your response must be concise. -2.20e+1. What is the difference between the Expenses (in $) of Ethiopia in 2006 and the Expenses (in $) of Hungary in 2010?
Your answer should be compact. -1.18e+12. What is the difference between the Expenses (in $) in Ethiopia in 2006 and the Expenses (in $) in Kyrgyz Republic in 2010?
Offer a terse response. -7.40e+09. What is the difference between the Expenses (in $) of Ethiopia in 2006 and the Expenses (in $) of Malaysia in 2010?
Your answer should be compact. -1.95e+1. What is the difference between the Expenses (in $) of Hungary in 2006 and the Expenses (in $) of Kyrgyz Republic in 2010?
Give a very brief answer. 9.15e+11. What is the difference between the Expenses (in $) in Hungary in 2006 and the Expenses (in $) in Malaysia in 2010?
Give a very brief answer. 9.03e+11. What is the difference between the Expenses (in $) in Kyrgyz Republic in 2006 and the Expenses (in $) in Malaysia in 2010?
Provide a succinct answer. -1.95e+1. What is the difference between the Expenses (in $) of Ethiopia in 2007 and the Expenses (in $) of Hungary in 2008?
Your answer should be very brief. -1.12e+12. What is the difference between the Expenses (in $) of Ethiopia in 2007 and the Expenses (in $) of Kyrgyz Republic in 2008?
Provide a succinct answer. -4.37e+09. What is the difference between the Expenses (in $) of Ethiopia in 2007 and the Expenses (in $) of Malaysia in 2008?
Provide a short and direct response. -2.05e+1. What is the difference between the Expenses (in $) of Hungary in 2007 and the Expenses (in $) of Kyrgyz Republic in 2008?
Keep it short and to the point. 9.78e+11. What is the difference between the Expenses (in $) in Hungary in 2007 and the Expenses (in $) in Malaysia in 2008?
Your answer should be compact. 9.61e+11. What is the difference between the Expenses (in $) in Kyrgyz Republic in 2007 and the Expenses (in $) in Malaysia in 2008?
Give a very brief answer. -1.88e+1. What is the difference between the Expenses (in $) of Ethiopia in 2007 and the Expenses (in $) of Hungary in 2009?
Offer a very short reply. -1.16e+12. What is the difference between the Expenses (in $) in Ethiopia in 2007 and the Expenses (in $) in Kyrgyz Republic in 2009?
Make the answer very short. -6.64e+09. What is the difference between the Expenses (in $) of Ethiopia in 2007 and the Expenses (in $) of Malaysia in 2009?
Your answer should be very brief. -2.17e+1. What is the difference between the Expenses (in $) of Hungary in 2007 and the Expenses (in $) of Kyrgyz Republic in 2009?
Your answer should be very brief. 9.75e+11. What is the difference between the Expenses (in $) of Hungary in 2007 and the Expenses (in $) of Malaysia in 2009?
Provide a short and direct response. 9.60e+11. What is the difference between the Expenses (in $) of Kyrgyz Republic in 2007 and the Expenses (in $) of Malaysia in 2009?
Offer a terse response. -2.00e+1. What is the difference between the Expenses (in $) in Ethiopia in 2007 and the Expenses (in $) in Hungary in 2010?
Offer a terse response. -1.18e+12. What is the difference between the Expenses (in $) of Ethiopia in 2007 and the Expenses (in $) of Kyrgyz Republic in 2010?
Your answer should be compact. -7.00e+09. What is the difference between the Expenses (in $) of Ethiopia in 2007 and the Expenses (in $) of Malaysia in 2010?
Offer a terse response. -1.91e+1. What is the difference between the Expenses (in $) of Hungary in 2007 and the Expenses (in $) of Kyrgyz Republic in 2010?
Make the answer very short. 9.75e+11. What is the difference between the Expenses (in $) of Hungary in 2007 and the Expenses (in $) of Malaysia in 2010?
Offer a terse response. 9.63e+11. What is the difference between the Expenses (in $) in Kyrgyz Republic in 2007 and the Expenses (in $) in Malaysia in 2010?
Your response must be concise. -1.75e+1. What is the difference between the Expenses (in $) of Ethiopia in 2008 and the Expenses (in $) of Hungary in 2009?
Give a very brief answer. -1.16e+12. What is the difference between the Expenses (in $) of Ethiopia in 2008 and the Expenses (in $) of Kyrgyz Republic in 2009?
Offer a very short reply. -6.31e+09. What is the difference between the Expenses (in $) of Ethiopia in 2008 and the Expenses (in $) of Malaysia in 2009?
Ensure brevity in your answer.  -2.13e+1. What is the difference between the Expenses (in $) of Hungary in 2008 and the Expenses (in $) of Kyrgyz Republic in 2009?
Your answer should be compact. 1.11e+12. What is the difference between the Expenses (in $) in Hungary in 2008 and the Expenses (in $) in Malaysia in 2009?
Offer a very short reply. 1.10e+12. What is the difference between the Expenses (in $) of Kyrgyz Republic in 2008 and the Expenses (in $) of Malaysia in 2009?
Your answer should be very brief. -1.73e+1. What is the difference between the Expenses (in $) of Ethiopia in 2008 and the Expenses (in $) of Hungary in 2010?
Your response must be concise. -1.18e+12. What is the difference between the Expenses (in $) of Ethiopia in 2008 and the Expenses (in $) of Kyrgyz Republic in 2010?
Your answer should be very brief. -6.67e+09. What is the difference between the Expenses (in $) in Ethiopia in 2008 and the Expenses (in $) in Malaysia in 2010?
Provide a succinct answer. -1.88e+1. What is the difference between the Expenses (in $) of Hungary in 2008 and the Expenses (in $) of Kyrgyz Republic in 2010?
Keep it short and to the point. 1.11e+12. What is the difference between the Expenses (in $) of Hungary in 2008 and the Expenses (in $) of Malaysia in 2010?
Offer a very short reply. 1.10e+12. What is the difference between the Expenses (in $) of Kyrgyz Republic in 2008 and the Expenses (in $) of Malaysia in 2010?
Provide a short and direct response. -1.48e+1. What is the difference between the Expenses (in $) in Ethiopia in 2009 and the Expenses (in $) in Hungary in 2010?
Ensure brevity in your answer.  -1.17e+12. What is the difference between the Expenses (in $) of Ethiopia in 2009 and the Expenses (in $) of Kyrgyz Republic in 2010?
Your response must be concise. -3.12e+09. What is the difference between the Expenses (in $) of Ethiopia in 2009 and the Expenses (in $) of Malaysia in 2010?
Your answer should be very brief. -1.53e+1. What is the difference between the Expenses (in $) of Hungary in 2009 and the Expenses (in $) of Kyrgyz Republic in 2010?
Your response must be concise. 1.15e+12. What is the difference between the Expenses (in $) of Hungary in 2009 and the Expenses (in $) of Malaysia in 2010?
Make the answer very short. 1.14e+12. What is the difference between the Expenses (in $) of Kyrgyz Republic in 2009 and the Expenses (in $) of Malaysia in 2010?
Offer a very short reply. -1.25e+1. What is the average Expenses (in $) of Ethiopia per year?
Your answer should be very brief. 5.24e+09. What is the average Expenses (in $) of Hungary per year?
Your response must be concise. 8.31e+11. What is the average Expenses (in $) of Kyrgyz Republic per year?
Make the answer very short. 6.62e+09. What is the average Expenses (in $) of Malaysia per year?
Keep it short and to the point. 1.83e+1. In the year 1998, what is the difference between the Expenses (in $) of Ethiopia and Expenses (in $) of Hungary?
Your answer should be compact. -3.45e+11. In the year 1998, what is the difference between the Expenses (in $) of Ethiopia and Expenses (in $) of Kyrgyz Republic?
Ensure brevity in your answer.  -4.95e+08. In the year 1998, what is the difference between the Expenses (in $) of Ethiopia and Expenses (in $) of Malaysia?
Give a very brief answer. -3.53e+09. In the year 1998, what is the difference between the Expenses (in $) in Hungary and Expenses (in $) in Kyrgyz Republic?
Your answer should be compact. 3.45e+11. In the year 1998, what is the difference between the Expenses (in $) in Hungary and Expenses (in $) in Malaysia?
Provide a succinct answer. 3.42e+11. In the year 1998, what is the difference between the Expenses (in $) of Kyrgyz Republic and Expenses (in $) of Malaysia?
Give a very brief answer. -3.03e+09. In the year 1999, what is the difference between the Expenses (in $) in Ethiopia and Expenses (in $) in Hungary?
Offer a very short reply. -4.07e+11. In the year 1999, what is the difference between the Expenses (in $) in Ethiopia and Expenses (in $) in Kyrgyz Republic?
Your response must be concise. 1.06e+09. In the year 1999, what is the difference between the Expenses (in $) in Ethiopia and Expenses (in $) in Malaysia?
Keep it short and to the point. -4.01e+09. In the year 1999, what is the difference between the Expenses (in $) of Hungary and Expenses (in $) of Kyrgyz Republic?
Give a very brief answer. 4.08e+11. In the year 1999, what is the difference between the Expenses (in $) in Hungary and Expenses (in $) in Malaysia?
Make the answer very short. 4.03e+11. In the year 1999, what is the difference between the Expenses (in $) of Kyrgyz Republic and Expenses (in $) of Malaysia?
Give a very brief answer. -5.07e+09. In the year 2001, what is the difference between the Expenses (in $) in Ethiopia and Expenses (in $) in Hungary?
Your answer should be compact. -5.07e+11. In the year 2001, what is the difference between the Expenses (in $) of Ethiopia and Expenses (in $) of Kyrgyz Republic?
Your answer should be compact. -1.75e+09. In the year 2001, what is the difference between the Expenses (in $) of Ethiopia and Expenses (in $) of Malaysia?
Your response must be concise. -9.74e+09. In the year 2001, what is the difference between the Expenses (in $) in Hungary and Expenses (in $) in Kyrgyz Republic?
Your answer should be very brief. 5.05e+11. In the year 2001, what is the difference between the Expenses (in $) in Hungary and Expenses (in $) in Malaysia?
Your response must be concise. 4.97e+11. In the year 2001, what is the difference between the Expenses (in $) in Kyrgyz Republic and Expenses (in $) in Malaysia?
Give a very brief answer. -7.99e+09. In the year 2006, what is the difference between the Expenses (in $) in Ethiopia and Expenses (in $) in Hungary?
Offer a terse response. -9.22e+11. In the year 2006, what is the difference between the Expenses (in $) of Ethiopia and Expenses (in $) of Kyrgyz Republic?
Offer a terse response. -3.42e+07. In the year 2006, what is the difference between the Expenses (in $) in Ethiopia and Expenses (in $) in Malaysia?
Offer a very short reply. -1.66e+1. In the year 2006, what is the difference between the Expenses (in $) of Hungary and Expenses (in $) of Kyrgyz Republic?
Your answer should be compact. 9.22e+11. In the year 2006, what is the difference between the Expenses (in $) of Hungary and Expenses (in $) of Malaysia?
Your answer should be very brief. 9.06e+11. In the year 2006, what is the difference between the Expenses (in $) in Kyrgyz Republic and Expenses (in $) in Malaysia?
Provide a short and direct response. -1.66e+1. In the year 2007, what is the difference between the Expenses (in $) in Ethiopia and Expenses (in $) in Hungary?
Give a very brief answer. -9.82e+11. In the year 2007, what is the difference between the Expenses (in $) in Ethiopia and Expenses (in $) in Kyrgyz Republic?
Ensure brevity in your answer.  -1.66e+09. In the year 2007, what is the difference between the Expenses (in $) in Ethiopia and Expenses (in $) in Malaysia?
Offer a very short reply. -1.89e+1. In the year 2007, what is the difference between the Expenses (in $) in Hungary and Expenses (in $) in Kyrgyz Republic?
Ensure brevity in your answer.  9.80e+11. In the year 2007, what is the difference between the Expenses (in $) in Hungary and Expenses (in $) in Malaysia?
Make the answer very short. 9.63e+11. In the year 2007, what is the difference between the Expenses (in $) of Kyrgyz Republic and Expenses (in $) of Malaysia?
Your response must be concise. -1.73e+1. In the year 2008, what is the difference between the Expenses (in $) of Ethiopia and Expenses (in $) of Hungary?
Give a very brief answer. -1.12e+12. In the year 2008, what is the difference between the Expenses (in $) of Ethiopia and Expenses (in $) of Kyrgyz Republic?
Keep it short and to the point. -4.04e+09. In the year 2008, what is the difference between the Expenses (in $) of Ethiopia and Expenses (in $) of Malaysia?
Provide a short and direct response. -2.02e+1. In the year 2008, what is the difference between the Expenses (in $) of Hungary and Expenses (in $) of Kyrgyz Republic?
Provide a short and direct response. 1.12e+12. In the year 2008, what is the difference between the Expenses (in $) in Hungary and Expenses (in $) in Malaysia?
Offer a very short reply. 1.10e+12. In the year 2008, what is the difference between the Expenses (in $) in Kyrgyz Republic and Expenses (in $) in Malaysia?
Make the answer very short. -1.61e+1. In the year 2009, what is the difference between the Expenses (in $) in Ethiopia and Expenses (in $) in Hungary?
Offer a terse response. -1.15e+12. In the year 2009, what is the difference between the Expenses (in $) of Ethiopia and Expenses (in $) of Kyrgyz Republic?
Your answer should be very brief. -2.76e+09. In the year 2009, what is the difference between the Expenses (in $) in Ethiopia and Expenses (in $) in Malaysia?
Your answer should be compact. -1.78e+1. In the year 2009, what is the difference between the Expenses (in $) of Hungary and Expenses (in $) of Kyrgyz Republic?
Give a very brief answer. 1.15e+12. In the year 2009, what is the difference between the Expenses (in $) of Hungary and Expenses (in $) of Malaysia?
Ensure brevity in your answer.  1.14e+12. In the year 2009, what is the difference between the Expenses (in $) in Kyrgyz Republic and Expenses (in $) in Malaysia?
Provide a short and direct response. -1.50e+1. In the year 2010, what is the difference between the Expenses (in $) of Ethiopia and Expenses (in $) of Hungary?
Provide a short and direct response. -1.17e+12. In the year 2010, what is the difference between the Expenses (in $) in Ethiopia and Expenses (in $) in Kyrgyz Republic?
Give a very brief answer. -1.35e+09. In the year 2010, what is the difference between the Expenses (in $) of Ethiopia and Expenses (in $) of Malaysia?
Offer a terse response. -1.35e+1. In the year 2010, what is the difference between the Expenses (in $) in Hungary and Expenses (in $) in Kyrgyz Republic?
Provide a short and direct response. 1.17e+12. In the year 2010, what is the difference between the Expenses (in $) in Hungary and Expenses (in $) in Malaysia?
Offer a very short reply. 1.16e+12. In the year 2010, what is the difference between the Expenses (in $) in Kyrgyz Republic and Expenses (in $) in Malaysia?
Ensure brevity in your answer.  -1.21e+1. What is the ratio of the Expenses (in $) of Ethiopia in 1998 to that in 1999?
Make the answer very short. 0.51. What is the ratio of the Expenses (in $) in Hungary in 1998 to that in 1999?
Provide a succinct answer. 0.85. What is the ratio of the Expenses (in $) in Kyrgyz Republic in 1998 to that in 1999?
Ensure brevity in your answer.  0.82. What is the ratio of the Expenses (in $) in Malaysia in 1998 to that in 1999?
Provide a succinct answer. 0.69. What is the ratio of the Expenses (in $) in Ethiopia in 1998 to that in 2001?
Ensure brevity in your answer.  1.03. What is the ratio of the Expenses (in $) of Hungary in 1998 to that in 2001?
Give a very brief answer. 0.68. What is the ratio of the Expenses (in $) in Kyrgyz Republic in 1998 to that in 2001?
Your answer should be compact. 0.7. What is the ratio of the Expenses (in $) in Malaysia in 1998 to that in 2001?
Your answer should be compact. 0.49. What is the ratio of the Expenses (in $) in Ethiopia in 1998 to that in 2006?
Give a very brief answer. 0.53. What is the ratio of the Expenses (in $) in Hungary in 1998 to that in 2006?
Keep it short and to the point. 0.38. What is the ratio of the Expenses (in $) in Kyrgyz Republic in 1998 to that in 2006?
Offer a terse response. 0.64. What is the ratio of the Expenses (in $) in Malaysia in 1998 to that in 2006?
Keep it short and to the point. 0.28. What is the ratio of the Expenses (in $) in Ethiopia in 1998 to that in 2007?
Ensure brevity in your answer.  0.48. What is the ratio of the Expenses (in $) of Hungary in 1998 to that in 2007?
Give a very brief answer. 0.35. What is the ratio of the Expenses (in $) of Kyrgyz Republic in 1998 to that in 2007?
Ensure brevity in your answer.  0.43. What is the ratio of the Expenses (in $) of Malaysia in 1998 to that in 2007?
Offer a very short reply. 0.25. What is the ratio of the Expenses (in $) in Ethiopia in 1998 to that in 2008?
Offer a terse response. 0.45. What is the ratio of the Expenses (in $) in Hungary in 1998 to that in 2008?
Your answer should be very brief. 0.31. What is the ratio of the Expenses (in $) in Kyrgyz Republic in 1998 to that in 2008?
Your answer should be very brief. 0.3. What is the ratio of the Expenses (in $) of Malaysia in 1998 to that in 2008?
Your answer should be compact. 0.23. What is the ratio of the Expenses (in $) in Ethiopia in 1998 to that in 2009?
Give a very brief answer. 0.26. What is the ratio of the Expenses (in $) of Hungary in 1998 to that in 2009?
Give a very brief answer. 0.3. What is the ratio of the Expenses (in $) in Kyrgyz Republic in 1998 to that in 2009?
Your answer should be compact. 0.24. What is the ratio of the Expenses (in $) in Malaysia in 1998 to that in 2009?
Your answer should be compact. 0.22. What is the ratio of the Expenses (in $) in Ethiopia in 1998 to that in 2010?
Provide a succinct answer. 0.22. What is the ratio of the Expenses (in $) of Hungary in 1998 to that in 2010?
Make the answer very short. 0.29. What is the ratio of the Expenses (in $) in Kyrgyz Republic in 1998 to that in 2010?
Ensure brevity in your answer.  0.24. What is the ratio of the Expenses (in $) in Malaysia in 1998 to that in 2010?
Your answer should be compact. 0.24. What is the ratio of the Expenses (in $) in Ethiopia in 1999 to that in 2001?
Your response must be concise. 2.02. What is the ratio of the Expenses (in $) of Hungary in 1999 to that in 2001?
Give a very brief answer. 0.81. What is the ratio of the Expenses (in $) in Kyrgyz Republic in 1999 to that in 2001?
Your answer should be compact. 0.85. What is the ratio of the Expenses (in $) of Malaysia in 1999 to that in 2001?
Provide a short and direct response. 0.71. What is the ratio of the Expenses (in $) in Hungary in 1999 to that in 2006?
Your answer should be very brief. 0.44. What is the ratio of the Expenses (in $) of Kyrgyz Republic in 1999 to that in 2006?
Give a very brief answer. 0.77. What is the ratio of the Expenses (in $) of Malaysia in 1999 to that in 2006?
Make the answer very short. 0.4. What is the ratio of the Expenses (in $) of Ethiopia in 1999 to that in 2007?
Provide a succinct answer. 0.94. What is the ratio of the Expenses (in $) in Hungary in 1999 to that in 2007?
Your answer should be compact. 0.42. What is the ratio of the Expenses (in $) in Kyrgyz Republic in 1999 to that in 2007?
Provide a succinct answer. 0.53. What is the ratio of the Expenses (in $) in Malaysia in 1999 to that in 2007?
Keep it short and to the point. 0.36. What is the ratio of the Expenses (in $) in Ethiopia in 1999 to that in 2008?
Keep it short and to the point. 0.88. What is the ratio of the Expenses (in $) in Hungary in 1999 to that in 2008?
Your answer should be compact. 0.37. What is the ratio of the Expenses (in $) in Kyrgyz Republic in 1999 to that in 2008?
Your answer should be compact. 0.37. What is the ratio of the Expenses (in $) of Malaysia in 1999 to that in 2008?
Your answer should be compact. 0.34. What is the ratio of the Expenses (in $) of Ethiopia in 1999 to that in 2009?
Give a very brief answer. 0.52. What is the ratio of the Expenses (in $) in Hungary in 1999 to that in 2009?
Make the answer very short. 0.35. What is the ratio of the Expenses (in $) of Kyrgyz Republic in 1999 to that in 2009?
Ensure brevity in your answer.  0.3. What is the ratio of the Expenses (in $) in Malaysia in 1999 to that in 2009?
Ensure brevity in your answer.  0.32. What is the ratio of the Expenses (in $) in Ethiopia in 1999 to that in 2010?
Ensure brevity in your answer.  0.43. What is the ratio of the Expenses (in $) in Hungary in 1999 to that in 2010?
Offer a terse response. 0.35. What is the ratio of the Expenses (in $) of Kyrgyz Republic in 1999 to that in 2010?
Your response must be concise. 0.29. What is the ratio of the Expenses (in $) of Malaysia in 1999 to that in 2010?
Offer a terse response. 0.35. What is the ratio of the Expenses (in $) in Ethiopia in 2001 to that in 2006?
Provide a short and direct response. 0.51. What is the ratio of the Expenses (in $) of Hungary in 2001 to that in 2006?
Your answer should be compact. 0.55. What is the ratio of the Expenses (in $) in Kyrgyz Republic in 2001 to that in 2006?
Provide a short and direct response. 0.91. What is the ratio of the Expenses (in $) in Malaysia in 2001 to that in 2006?
Your response must be concise. 0.57. What is the ratio of the Expenses (in $) of Ethiopia in 2001 to that in 2007?
Your response must be concise. 0.47. What is the ratio of the Expenses (in $) in Hungary in 2001 to that in 2007?
Give a very brief answer. 0.52. What is the ratio of the Expenses (in $) of Kyrgyz Republic in 2001 to that in 2007?
Make the answer very short. 0.62. What is the ratio of the Expenses (in $) in Malaysia in 2001 to that in 2007?
Provide a short and direct response. 0.51. What is the ratio of the Expenses (in $) in Ethiopia in 2001 to that in 2008?
Keep it short and to the point. 0.44. What is the ratio of the Expenses (in $) in Hungary in 2001 to that in 2008?
Your answer should be compact. 0.45. What is the ratio of the Expenses (in $) of Kyrgyz Republic in 2001 to that in 2008?
Offer a very short reply. 0.43. What is the ratio of the Expenses (in $) of Malaysia in 2001 to that in 2008?
Offer a terse response. 0.47. What is the ratio of the Expenses (in $) in Ethiopia in 2001 to that in 2009?
Give a very brief answer. 0.26. What is the ratio of the Expenses (in $) of Hungary in 2001 to that in 2009?
Provide a short and direct response. 0.44. What is the ratio of the Expenses (in $) of Kyrgyz Republic in 2001 to that in 2009?
Provide a succinct answer. 0.35. What is the ratio of the Expenses (in $) in Malaysia in 2001 to that in 2009?
Your answer should be very brief. 0.45. What is the ratio of the Expenses (in $) in Ethiopia in 2001 to that in 2010?
Offer a terse response. 0.21. What is the ratio of the Expenses (in $) in Hungary in 2001 to that in 2010?
Give a very brief answer. 0.43. What is the ratio of the Expenses (in $) in Kyrgyz Republic in 2001 to that in 2010?
Your answer should be compact. 0.34. What is the ratio of the Expenses (in $) in Malaysia in 2001 to that in 2010?
Your answer should be very brief. 0.5. What is the ratio of the Expenses (in $) of Ethiopia in 2006 to that in 2007?
Offer a terse response. 0.92. What is the ratio of the Expenses (in $) in Hungary in 2006 to that in 2007?
Your response must be concise. 0.94. What is the ratio of the Expenses (in $) of Kyrgyz Republic in 2006 to that in 2007?
Your answer should be very brief. 0.68. What is the ratio of the Expenses (in $) of Malaysia in 2006 to that in 2007?
Give a very brief answer. 0.89. What is the ratio of the Expenses (in $) in Ethiopia in 2006 to that in 2008?
Provide a short and direct response. 0.86. What is the ratio of the Expenses (in $) of Hungary in 2006 to that in 2008?
Your answer should be very brief. 0.82. What is the ratio of the Expenses (in $) in Kyrgyz Republic in 2006 to that in 2008?
Your response must be concise. 0.48. What is the ratio of the Expenses (in $) in Malaysia in 2006 to that in 2008?
Ensure brevity in your answer.  0.83. What is the ratio of the Expenses (in $) in Ethiopia in 2006 to that in 2009?
Make the answer very short. 0.5. What is the ratio of the Expenses (in $) in Hungary in 2006 to that in 2009?
Provide a short and direct response. 0.8. What is the ratio of the Expenses (in $) in Kyrgyz Republic in 2006 to that in 2009?
Offer a terse response. 0.38. What is the ratio of the Expenses (in $) in Malaysia in 2006 to that in 2009?
Provide a succinct answer. 0.79. What is the ratio of the Expenses (in $) of Ethiopia in 2006 to that in 2010?
Ensure brevity in your answer.  0.42. What is the ratio of the Expenses (in $) of Hungary in 2006 to that in 2010?
Offer a terse response. 0.78. What is the ratio of the Expenses (in $) of Kyrgyz Republic in 2006 to that in 2010?
Your response must be concise. 0.37. What is the ratio of the Expenses (in $) of Malaysia in 2006 to that in 2010?
Provide a succinct answer. 0.88. What is the ratio of the Expenses (in $) in Ethiopia in 2007 to that in 2008?
Offer a very short reply. 0.93. What is the ratio of the Expenses (in $) in Hungary in 2007 to that in 2008?
Give a very brief answer. 0.88. What is the ratio of the Expenses (in $) of Kyrgyz Republic in 2007 to that in 2008?
Keep it short and to the point. 0.7. What is the ratio of the Expenses (in $) in Ethiopia in 2007 to that in 2009?
Ensure brevity in your answer.  0.55. What is the ratio of the Expenses (in $) of Hungary in 2007 to that in 2009?
Give a very brief answer. 0.85. What is the ratio of the Expenses (in $) of Kyrgyz Republic in 2007 to that in 2009?
Provide a succinct answer. 0.56. What is the ratio of the Expenses (in $) of Malaysia in 2007 to that in 2009?
Provide a succinct answer. 0.9. What is the ratio of the Expenses (in $) of Ethiopia in 2007 to that in 2010?
Offer a terse response. 0.45. What is the ratio of the Expenses (in $) of Hungary in 2007 to that in 2010?
Keep it short and to the point. 0.83. What is the ratio of the Expenses (in $) in Kyrgyz Republic in 2007 to that in 2010?
Offer a very short reply. 0.54. What is the ratio of the Expenses (in $) in Malaysia in 2007 to that in 2010?
Provide a short and direct response. 0.99. What is the ratio of the Expenses (in $) in Ethiopia in 2008 to that in 2009?
Your answer should be very brief. 0.59. What is the ratio of the Expenses (in $) in Hungary in 2008 to that in 2009?
Provide a short and direct response. 0.97. What is the ratio of the Expenses (in $) of Kyrgyz Republic in 2008 to that in 2009?
Make the answer very short. 0.8. What is the ratio of the Expenses (in $) of Malaysia in 2008 to that in 2009?
Provide a succinct answer. 0.96. What is the ratio of the Expenses (in $) in Ethiopia in 2008 to that in 2010?
Your answer should be compact. 0.49. What is the ratio of the Expenses (in $) of Hungary in 2008 to that in 2010?
Give a very brief answer. 0.95. What is the ratio of the Expenses (in $) of Kyrgyz Republic in 2008 to that in 2010?
Your answer should be compact. 0.78. What is the ratio of the Expenses (in $) in Malaysia in 2008 to that in 2010?
Make the answer very short. 1.06. What is the ratio of the Expenses (in $) of Ethiopia in 2009 to that in 2010?
Provide a short and direct response. 0.83. What is the ratio of the Expenses (in $) in Hungary in 2009 to that in 2010?
Give a very brief answer. 0.98. What is the ratio of the Expenses (in $) in Kyrgyz Republic in 2009 to that in 2010?
Your answer should be very brief. 0.97. What is the ratio of the Expenses (in $) in Malaysia in 2009 to that in 2010?
Your response must be concise. 1.11. What is the difference between the highest and the second highest Expenses (in $) of Ethiopia?
Your answer should be compact. 1.78e+09. What is the difference between the highest and the second highest Expenses (in $) of Hungary?
Provide a short and direct response. 2.05e+1. What is the difference between the highest and the second highest Expenses (in $) in Kyrgyz Republic?
Give a very brief answer. 3.61e+08. What is the difference between the highest and the second highest Expenses (in $) of Malaysia?
Your response must be concise. 1.18e+09. What is the difference between the highest and the lowest Expenses (in $) in Ethiopia?
Make the answer very short. 8.17e+09. What is the difference between the highest and the lowest Expenses (in $) in Hungary?
Your response must be concise. 8.35e+11. What is the difference between the highest and the lowest Expenses (in $) of Kyrgyz Republic?
Your response must be concise. 8.95e+09. What is the difference between the highest and the lowest Expenses (in $) of Malaysia?
Provide a succinct answer. 2.06e+1. 